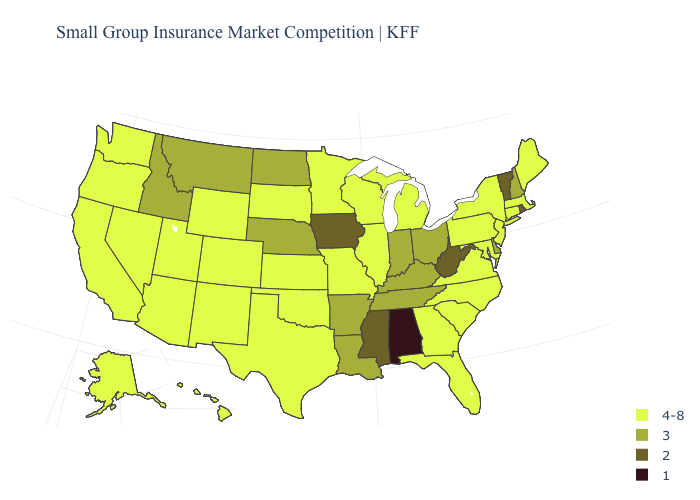Name the states that have a value in the range 1?
Be succinct. Alabama. What is the value of Wyoming?
Be succinct. 4-8. What is the lowest value in states that border Tennessee?
Quick response, please. 1. What is the value of Alaska?
Short answer required. 4-8. Name the states that have a value in the range 3?
Be succinct. Arkansas, Delaware, Idaho, Indiana, Kentucky, Louisiana, Montana, Nebraska, New Hampshire, North Dakota, Ohio, Tennessee. What is the value of Tennessee?
Concise answer only. 3. Does Arkansas have a higher value than New York?
Quick response, please. No. Name the states that have a value in the range 4-8?
Answer briefly. Alaska, Arizona, California, Colorado, Connecticut, Florida, Georgia, Hawaii, Illinois, Kansas, Maine, Maryland, Massachusetts, Michigan, Minnesota, Missouri, Nevada, New Jersey, New Mexico, New York, North Carolina, Oklahoma, Oregon, Pennsylvania, South Carolina, South Dakota, Texas, Utah, Virginia, Washington, Wisconsin, Wyoming. Name the states that have a value in the range 2?
Write a very short answer. Iowa, Mississippi, Rhode Island, Vermont, West Virginia. Does the map have missing data?
Short answer required. No. What is the value of Wisconsin?
Answer briefly. 4-8. What is the lowest value in the USA?
Keep it brief. 1. Does Utah have the same value as Wisconsin?
Concise answer only. Yes. What is the value of North Dakota?
Be succinct. 3. Name the states that have a value in the range 2?
Answer briefly. Iowa, Mississippi, Rhode Island, Vermont, West Virginia. 